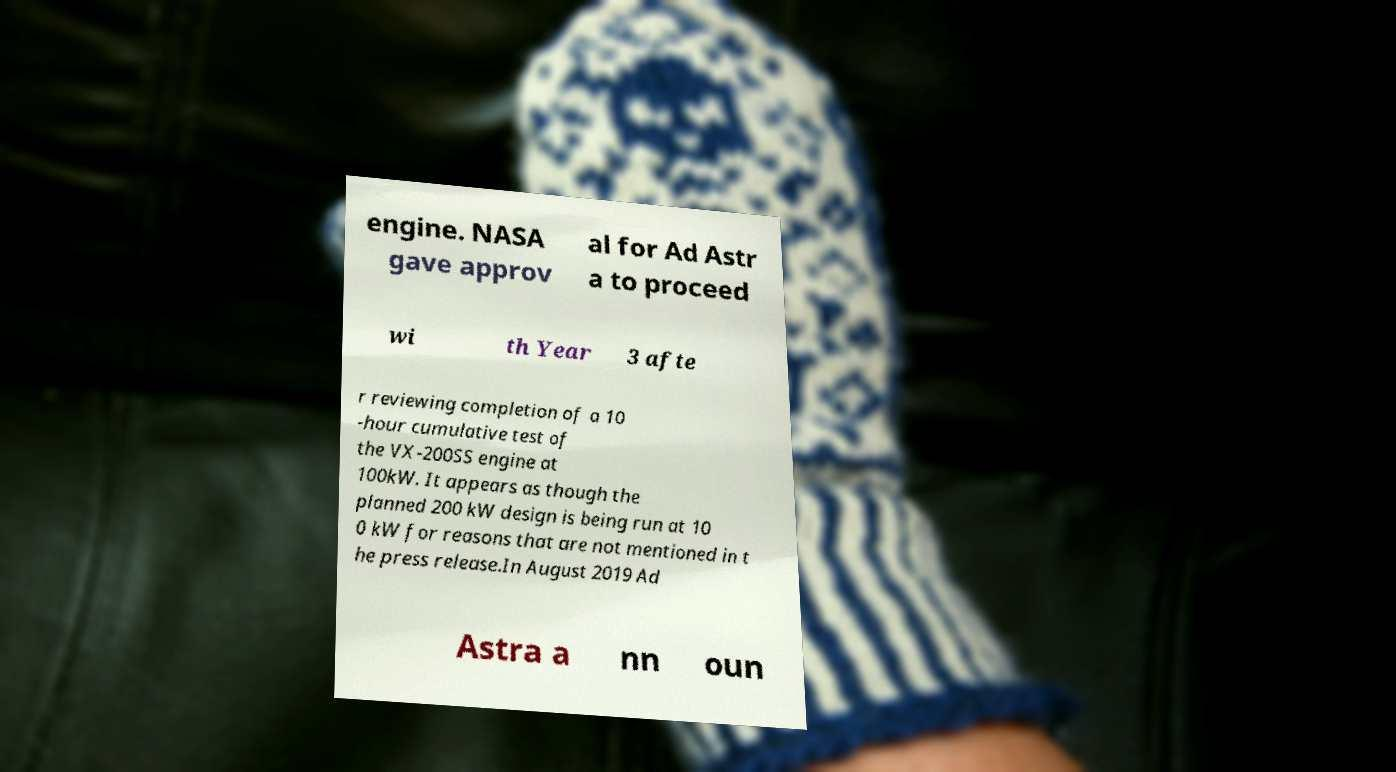Can you accurately transcribe the text from the provided image for me? engine. NASA gave approv al for Ad Astr a to proceed wi th Year 3 afte r reviewing completion of a 10 -hour cumulative test of the VX-200SS engine at 100kW. It appears as though the planned 200 kW design is being run at 10 0 kW for reasons that are not mentioned in t he press release.In August 2019 Ad Astra a nn oun 